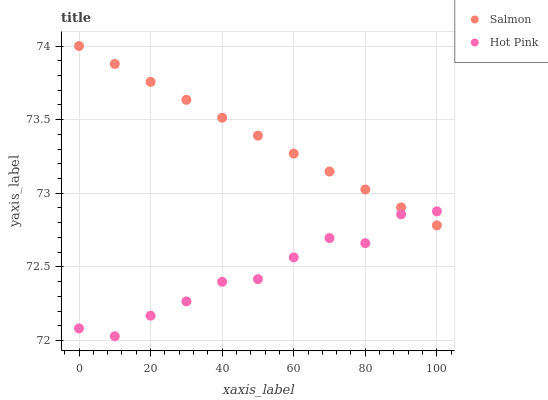Does Hot Pink have the minimum area under the curve?
Answer yes or no. Yes. Does Salmon have the maximum area under the curve?
Answer yes or no. Yes. Does Salmon have the minimum area under the curve?
Answer yes or no. No. Is Salmon the smoothest?
Answer yes or no. Yes. Is Hot Pink the roughest?
Answer yes or no. Yes. Is Salmon the roughest?
Answer yes or no. No. Does Hot Pink have the lowest value?
Answer yes or no. Yes. Does Salmon have the lowest value?
Answer yes or no. No. Does Salmon have the highest value?
Answer yes or no. Yes. Does Hot Pink intersect Salmon?
Answer yes or no. Yes. Is Hot Pink less than Salmon?
Answer yes or no. No. Is Hot Pink greater than Salmon?
Answer yes or no. No. 